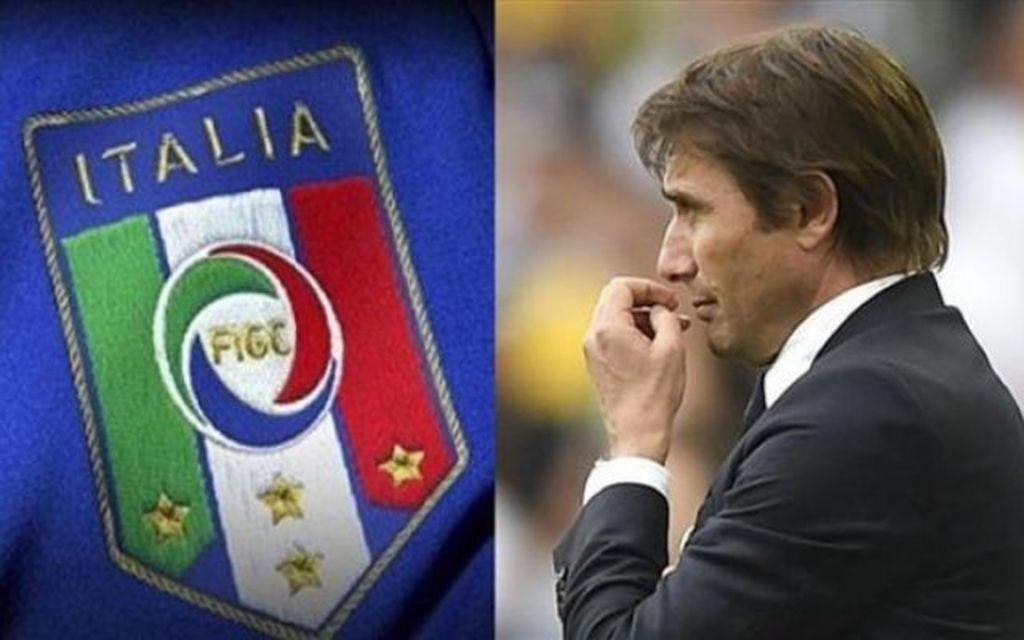Who is the main subject in the foreground of the picture? There is a man in the foreground of the picture. On which side of the image is the man located? The man is on the right side of the image. What is the man wearing in the picture? The man is wearing a black coat. What can be seen on the left side of the image? There is a blue flag on the left side of the image. What is written on the flag? The text "ITALIA" is written on the flag. What type of leather is visible on the man's shoes in the image? There is no information about the man's shoes in the provided facts, so we cannot determine the type of leather present. 